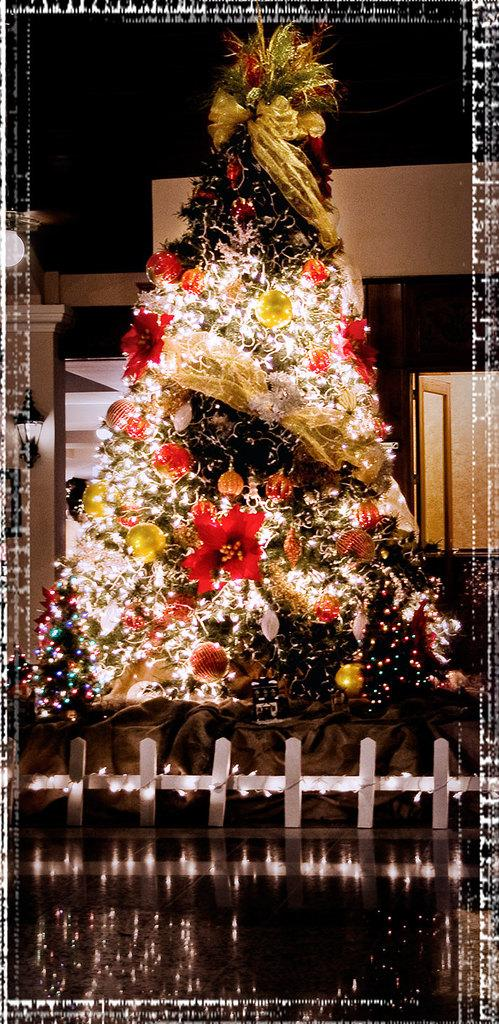What is the main subject of the image? There is a Christmas tree in the image. What can be seen on the Christmas tree? The Christmas tree has decorative items and lights. What can be seen in the background of the image? There is a wall, a light, and a window in the background of the image. Who is the owner of the coastline visible in the image? There is no coastline visible in the image; it features a Christmas tree with decorations and lights, along with a wall, a light, and a window in the background. 